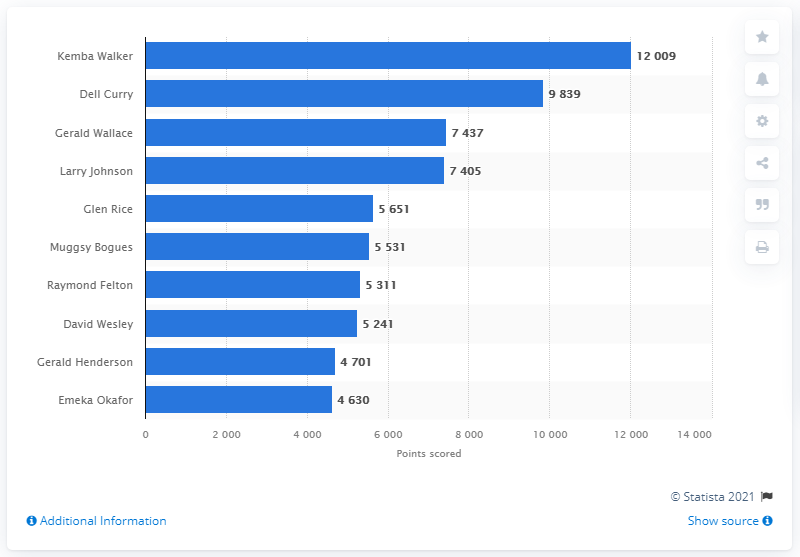Specify some key components in this picture. Kemba Walker is the career points leader of the Charlotte Hornets. 